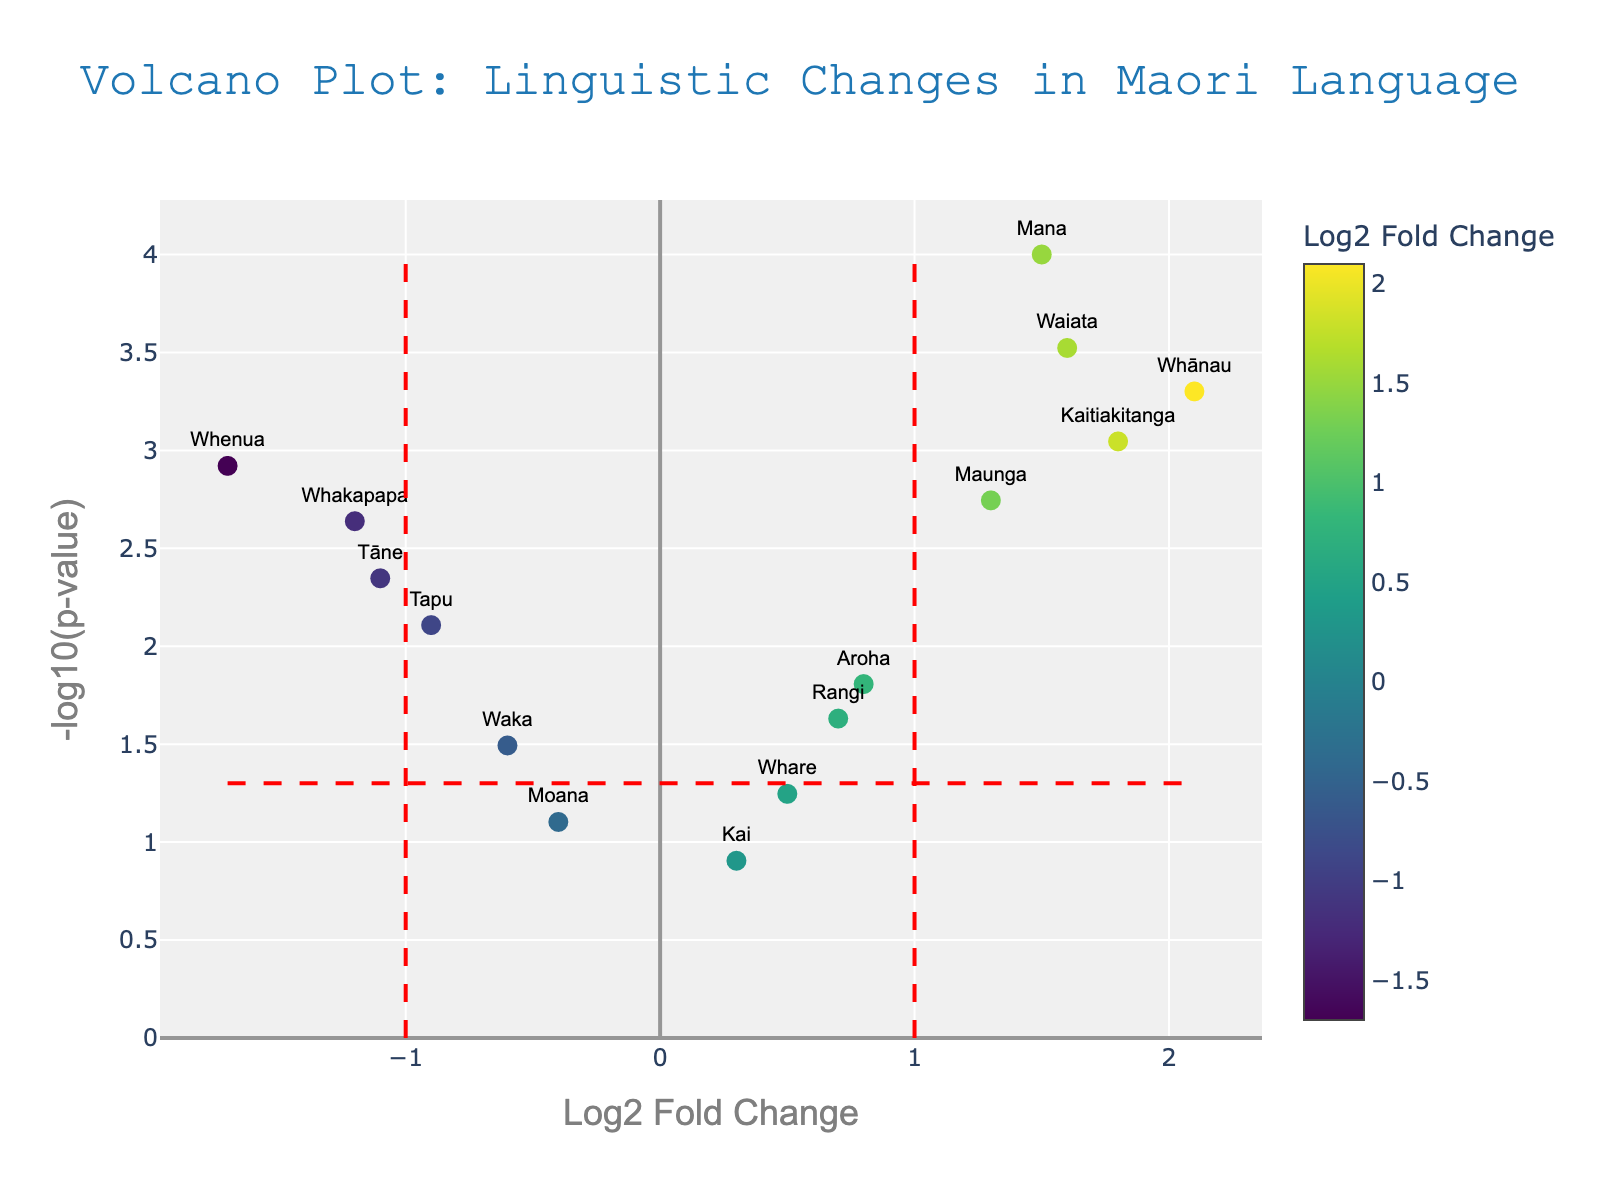How many words have a log2 fold change greater than 1? We need to count the number of data points that have a log2 fold change greater than 1. Looking at the plot, the words with log2 fold changes greater than 1 are Mana, Whānau, Kaitiakitanga, Maunga, and Waiata. So, there are 5 such words.
Answer: 5 Which word has the lowest p-value? The word with the lowest p-value would appear higher on the y-axis since the y-axis is -log10(p-value). From the plot, the word Mana, with a log2 fold change of about 1.5, is the highest point on the y-axis, so it has the lowest p-value.
Answer: Mana What is the log2 fold change and corresponding p-value for the word "Whakapapa"? The word "Whakapapa" is labeled on the plot with a log2 fold change of about -1.2 and a p-value as indicated by its position. The hover text usually reveals exact values: Log2 FC: -1.2 and p-value: 0.0023.
Answer: Log2 FC: -1.2, p-value: 0.0023 Which word shows the greatest decrease in usage based on log2 fold change? We need to find the word with the most negative log2 fold change. From the plot, the words with negative log2 fold changes appear on the left side. "Whenua" has the lowest log2 fold change of about -1.7, indicating the greatest decrease in usage.
Answer: Whenua Are there more words with a significant increase or decrease in usage (log2 fold change beyond ±1 and p-value < 0.05)? We look for words that are located outside the range of -1 to 1 log2 fold change and have a -log10(p-value) above the threshold line (-log10(0.05) ≈ 1.3). These words are Mana, Whānau, Kaitiakitanga, Maunga, and Waiata for increase and Whakapapa, Tapu, Whenua, and Tāne for decrease. There are 5 words with a significant increase and 4 with a significant decrease.
Answer: Increase What are the log2 fold changes for "Aroha" and "Waiata," and which of the two has a higher log2 fold change? Look at the position of "Aroha" and "Waiata" on the x-axis. "Aroha" has a log2 fold change of approximately 0.8, while "Waiata" has a log2 fold change of approximately 1.6. Since 1.6 > 0.8, "Waiata" has a higher log2 fold change.
Answer: Aroha: 0.8, Waiata: 1.6, Waiata is higher Which word has the highest -log10(p-value)? The word with the highest -log10(p-value) is the one highest on the y-axis. From the plot, this word is "Mana," at the top.
Answer: Mana How many words have a p-value greater than 0.05? A p-value greater than 0.05 corresponds to points below the horizontal red line (since -log10(0.05) ≈ 1.3). The words we see under this line are "Kai," "Whare," "Moana," and "Waka." Thus, there are 4 such words.
Answer: 4 